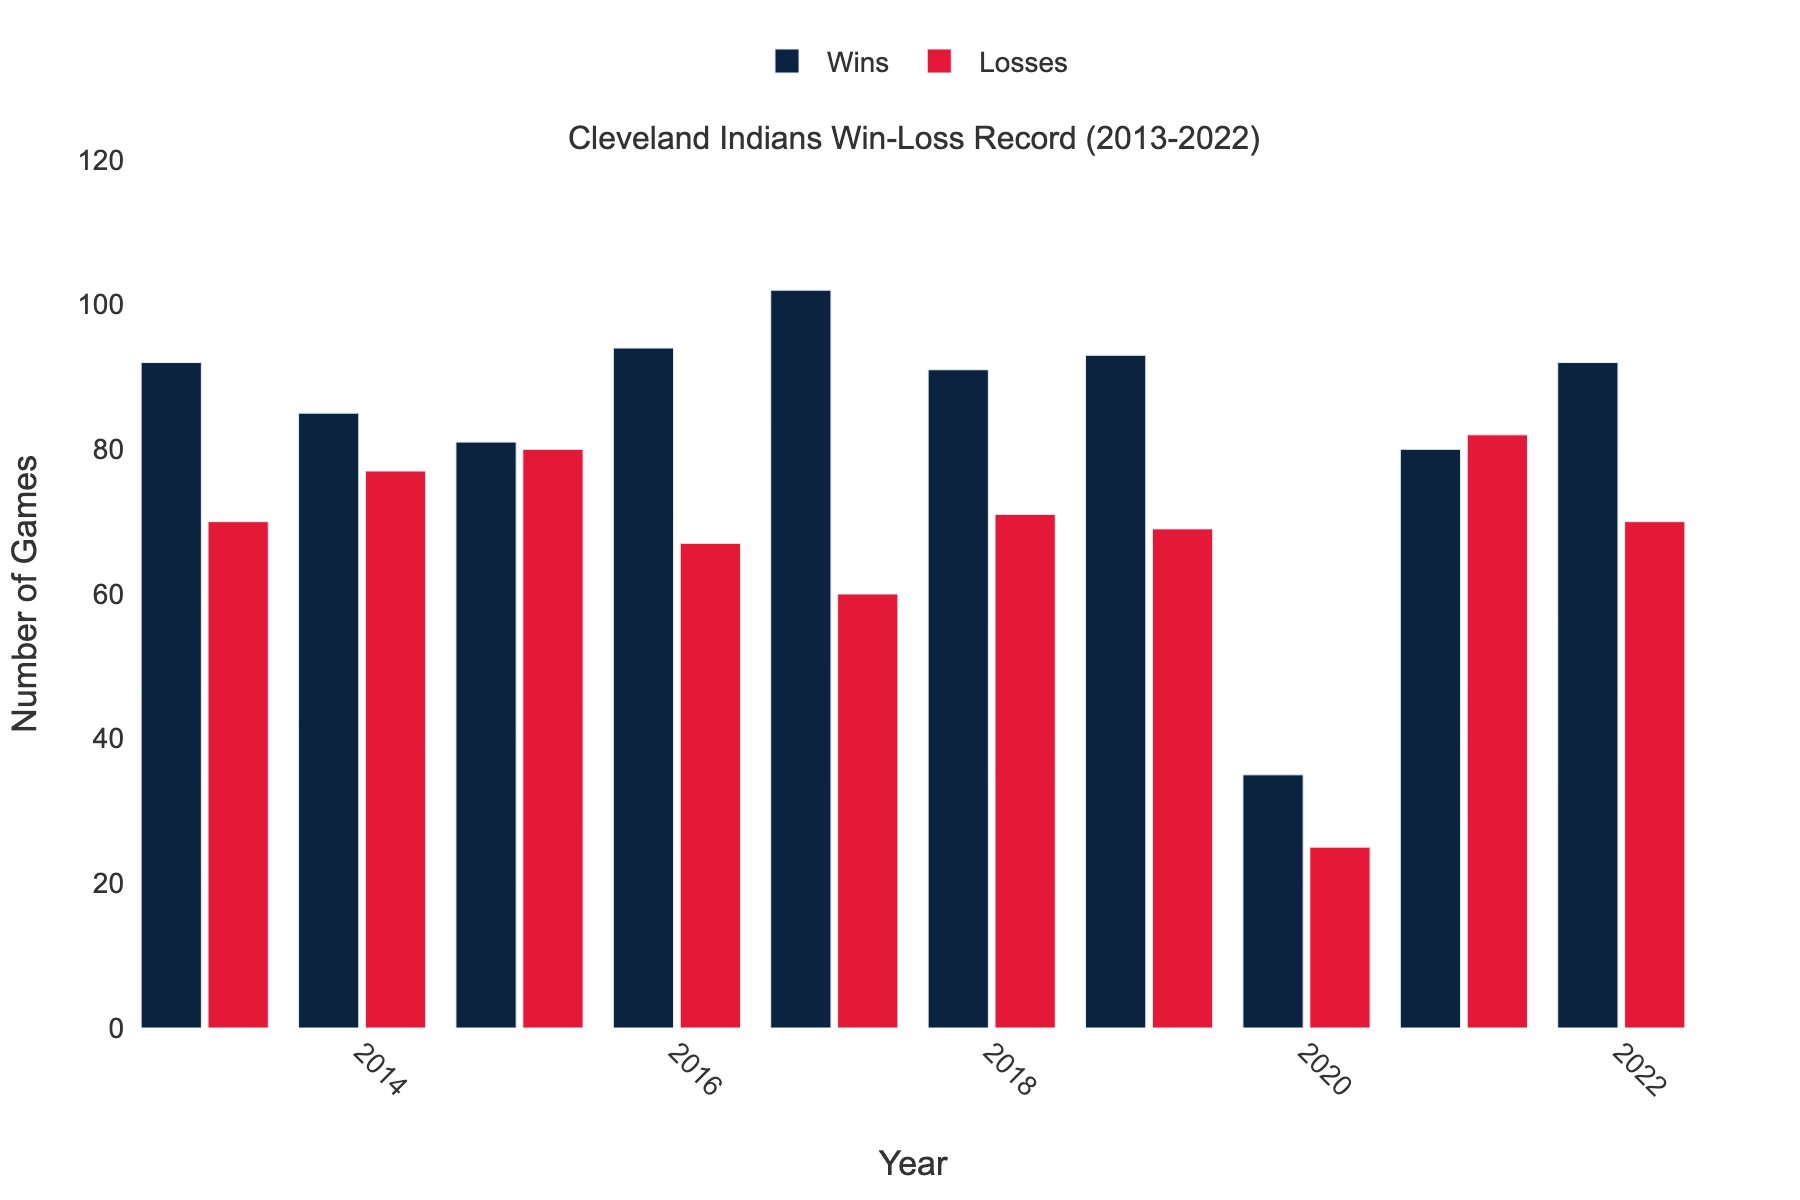Which year had the highest number of wins? The highest bar in the "Wins" category represents the year with the most wins. By visually comparing the heights, the highest bar is in 2017.
Answer: 2017 How many more wins were there in 2020 compared to losses in 2020? In 2020, the number of wins is 35 and the number of losses is 25. The difference is 35 - 25 = 10.
Answer: 10 In which years did the team have more wins than losses? Visually identify the years where the height of the "Wins" bar is greater than the height of the "Losses" bar. These years are 2013, 2014, 2016, 2017, 2018, 2019, 2020, and 2022.
Answer: 2013, 2014, 2016, 2017, 2018, 2019, 2020, 2022 What is the average number of wins from 2013 to 2022? Sum the number of wins for all years (92+85+81+94+102+91+93+35+80+92 = 845) and then divide by the number of years (10). The average is 845 / 10 = 84.5.
Answer: 84.5 Which year had the smallest difference between wins and losses? Calculate the differences for each year and compare them. The differences are 2013: 22, 2014: 8, 2015: 1, 2016: 27, 2017: 42, 2018: 20, 2019: 24, 2020: 10, 2021: 2, 2022: 22. The smallest difference is in 2015 (1).
Answer: 2015 What's the ratio of wins to losses in 2018? In 2018, the number of wins is 91 and the number of losses is 71. The ratio is 91 / 71 = 1.282.
Answer: 1.282 How did the number of wins in 2019 compare to 2020? The number of wins in 2019 is 93, while in 2020 it is 35. 93 is greater than 35.
Answer: 2019 had more wins What is the total number of losses from 2017 to 2021? Sum the number of losses for these years (60 + 71 + 69 + 25 + 82 = 307). The total is 307.
Answer: 307 In which year did the team have its best performance in terms of win-loss difference? The best performance is indicated by the highest positive difference between wins and losses. Calculate the win-loss difference for each year, the biggest positive difference is in 2017 with a difference of 42.
Answer: 2017 Can you find a year where the team had an equal number of wins and losses? Compare the heights of bars for wins and losses for each year. In none of the years do the wins and losses bars appear equal.
Answer: No 